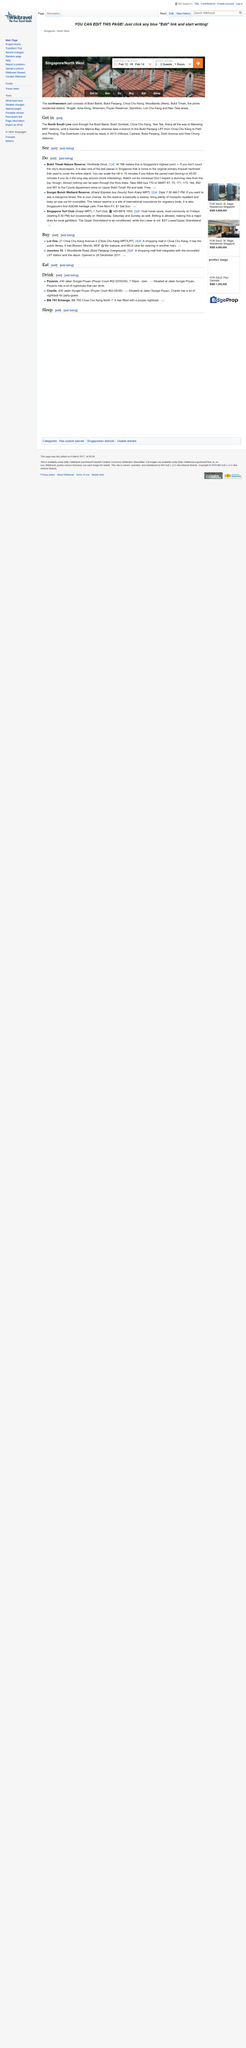Identify some key points in this picture. The Sungei Buloh Wetland Reserve is the first ASEAN heritage park in Singapore. Bukit Timah Nature Reserve, with a height of 166 meters, is Singapore's highest point not counting skyscrapers, according to "Do". The Bukit Timah Nature Reserve is the location of the original primary tropical rainforest that once covered the entire island. 